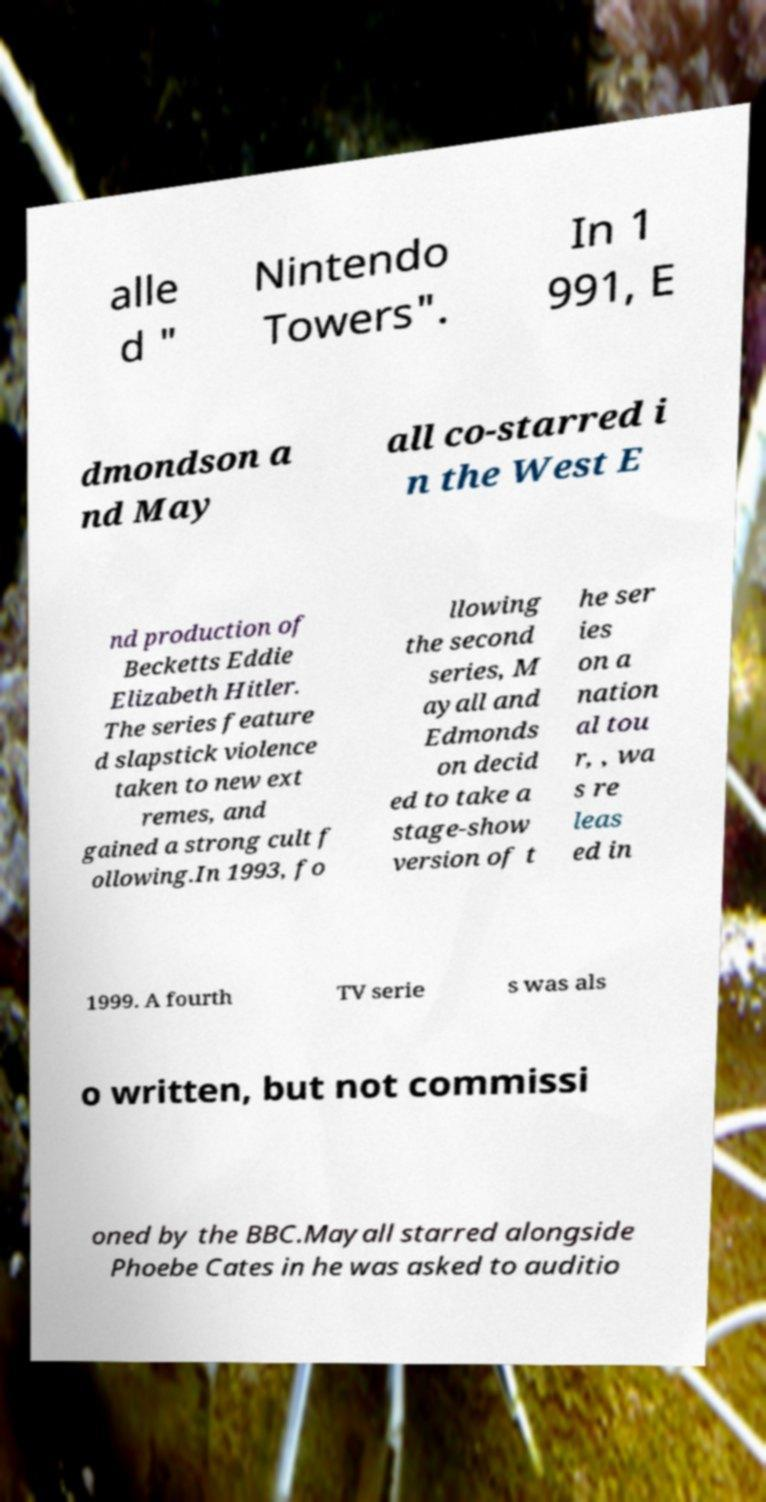There's text embedded in this image that I need extracted. Can you transcribe it verbatim? alle d " Nintendo Towers". In 1 991, E dmondson a nd May all co-starred i n the West E nd production of Becketts Eddie Elizabeth Hitler. The series feature d slapstick violence taken to new ext remes, and gained a strong cult f ollowing.In 1993, fo llowing the second series, M ayall and Edmonds on decid ed to take a stage-show version of t he ser ies on a nation al tou r, , wa s re leas ed in 1999. A fourth TV serie s was als o written, but not commissi oned by the BBC.Mayall starred alongside Phoebe Cates in he was asked to auditio 